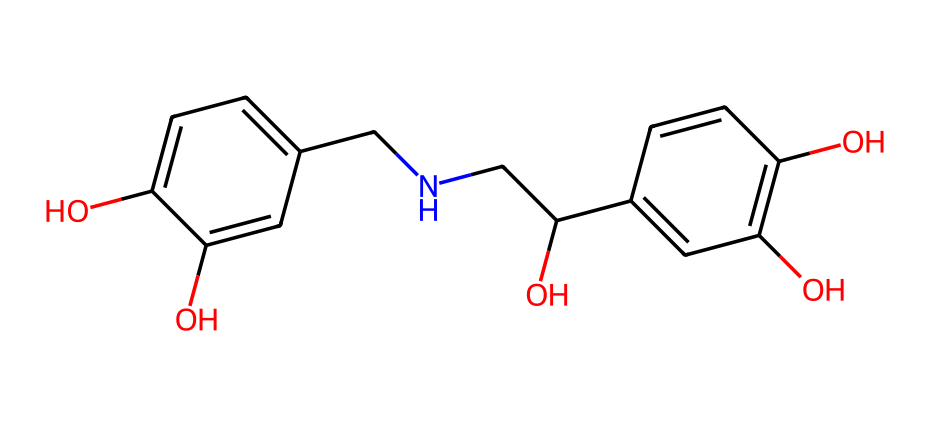What is the molecular formula of adrenaline? To determine the molecular formula, we count the number of different atoms in the chemical structure indicated by the SMILES representation. From the rendered structure, we identify carbon (C), hydrogen (H), nitrogen (N), and oxygen (O) atoms. After counting, we find there are 9 carbon atoms, 13 hydrogen atoms, 1 nitrogen atom, and 3 oxygen atoms, leading to the molecular formula C9H13NO3.
Answer: C9H13NO3 How many hydroxyl (-OH) groups are present in adrenaline? By examining the chemical structure, we can identify the hydroxyl groups as they are represented by the -OH functional groups in the molecule. In the structure provided, there are three distinct -OH groups attached at different positions.
Answer: 3 What is the role of nitrogen in adrenaline? The nitrogen atom present in the chemical structure plays a crucial role in the functionality of adrenaline. It is part of the amino group, allowing the molecule to interact with specific receptors in the body. This interaction is essential for the physiological effects associated with adrenaline, such as increased heart rate and energy mobilization.
Answer: receptor interaction How many rings are present in the structure of adrenaline? A careful analysis of the structure shows that there is one aromatic ring composed of six carbon atoms. This ring can be identified as the phenolic part of the adrenaline structure. There are no additional cycles or rings present in the molecule.
Answer: 1 Why does adrenaline belong to the category of biochemicals? Adrenaline is classified as a biochemical because it is a naturally occurring hormone produced in the body, specifically by the adrenal glands. Biochemicals are substances involved in the chemical processes within living organisms, and adrenal hormones like adrenaline play significant roles in stress response and metabolism.
Answer: naturally occurring hormone 